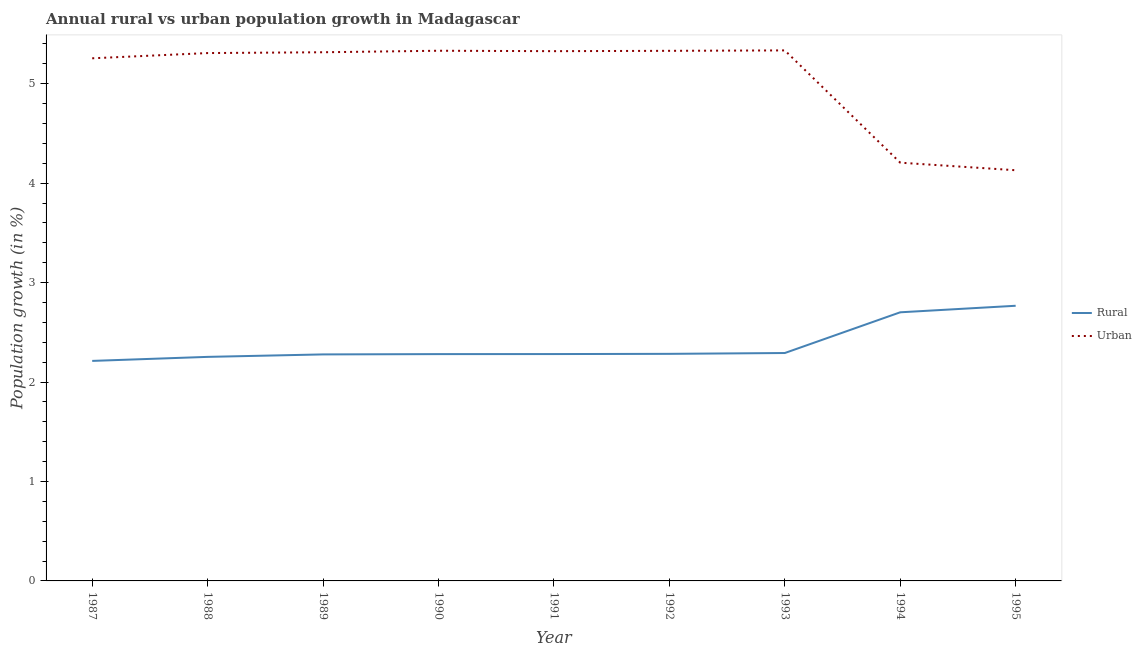What is the rural population growth in 1994?
Provide a short and direct response. 2.7. Across all years, what is the maximum rural population growth?
Provide a succinct answer. 2.77. Across all years, what is the minimum urban population growth?
Keep it short and to the point. 4.13. What is the total urban population growth in the graph?
Offer a terse response. 45.54. What is the difference between the urban population growth in 1989 and that in 1992?
Ensure brevity in your answer.  -0.01. What is the difference between the rural population growth in 1989 and the urban population growth in 1992?
Keep it short and to the point. -3.05. What is the average rural population growth per year?
Offer a very short reply. 2.37. In the year 1990, what is the difference between the rural population growth and urban population growth?
Make the answer very short. -3.05. What is the ratio of the rural population growth in 1993 to that in 1994?
Give a very brief answer. 0.85. Is the urban population growth in 1988 less than that in 1989?
Your response must be concise. Yes. What is the difference between the highest and the second highest urban population growth?
Offer a very short reply. 0. What is the difference between the highest and the lowest rural population growth?
Provide a short and direct response. 0.55. Is the urban population growth strictly less than the rural population growth over the years?
Make the answer very short. No. How many lines are there?
Your answer should be compact. 2. Does the graph contain any zero values?
Offer a terse response. No. Where does the legend appear in the graph?
Ensure brevity in your answer.  Center right. What is the title of the graph?
Your response must be concise. Annual rural vs urban population growth in Madagascar. Does "Age 65(male)" appear as one of the legend labels in the graph?
Make the answer very short. No. What is the label or title of the Y-axis?
Provide a succinct answer. Population growth (in %). What is the Population growth (in %) in Rural in 1987?
Give a very brief answer. 2.21. What is the Population growth (in %) of Urban  in 1987?
Your answer should be very brief. 5.26. What is the Population growth (in %) in Rural in 1988?
Give a very brief answer. 2.25. What is the Population growth (in %) in Urban  in 1988?
Your response must be concise. 5.31. What is the Population growth (in %) in Rural in 1989?
Your answer should be very brief. 2.28. What is the Population growth (in %) of Urban  in 1989?
Provide a short and direct response. 5.32. What is the Population growth (in %) of Rural in 1990?
Give a very brief answer. 2.28. What is the Population growth (in %) of Urban  in 1990?
Provide a short and direct response. 5.33. What is the Population growth (in %) of Rural in 1991?
Provide a short and direct response. 2.28. What is the Population growth (in %) of Urban  in 1991?
Ensure brevity in your answer.  5.33. What is the Population growth (in %) of Rural in 1992?
Ensure brevity in your answer.  2.28. What is the Population growth (in %) of Urban  in 1992?
Give a very brief answer. 5.33. What is the Population growth (in %) of Rural in 1993?
Offer a terse response. 2.29. What is the Population growth (in %) in Urban  in 1993?
Offer a very short reply. 5.33. What is the Population growth (in %) of Rural in 1994?
Offer a terse response. 2.7. What is the Population growth (in %) in Urban  in 1994?
Offer a terse response. 4.21. What is the Population growth (in %) of Rural in 1995?
Offer a terse response. 2.77. What is the Population growth (in %) in Urban  in 1995?
Your answer should be very brief. 4.13. Across all years, what is the maximum Population growth (in %) in Rural?
Your answer should be compact. 2.77. Across all years, what is the maximum Population growth (in %) in Urban ?
Your response must be concise. 5.33. Across all years, what is the minimum Population growth (in %) in Rural?
Keep it short and to the point. 2.21. Across all years, what is the minimum Population growth (in %) of Urban ?
Your response must be concise. 4.13. What is the total Population growth (in %) of Rural in the graph?
Provide a short and direct response. 21.35. What is the total Population growth (in %) in Urban  in the graph?
Offer a terse response. 45.54. What is the difference between the Population growth (in %) of Rural in 1987 and that in 1988?
Your answer should be very brief. -0.04. What is the difference between the Population growth (in %) in Urban  in 1987 and that in 1988?
Offer a very short reply. -0.05. What is the difference between the Population growth (in %) in Rural in 1987 and that in 1989?
Provide a succinct answer. -0.07. What is the difference between the Population growth (in %) in Urban  in 1987 and that in 1989?
Make the answer very short. -0.06. What is the difference between the Population growth (in %) in Rural in 1987 and that in 1990?
Offer a terse response. -0.07. What is the difference between the Population growth (in %) in Urban  in 1987 and that in 1990?
Provide a succinct answer. -0.08. What is the difference between the Population growth (in %) of Rural in 1987 and that in 1991?
Your answer should be very brief. -0.07. What is the difference between the Population growth (in %) of Urban  in 1987 and that in 1991?
Give a very brief answer. -0.07. What is the difference between the Population growth (in %) of Rural in 1987 and that in 1992?
Provide a short and direct response. -0.07. What is the difference between the Population growth (in %) of Urban  in 1987 and that in 1992?
Your response must be concise. -0.07. What is the difference between the Population growth (in %) in Rural in 1987 and that in 1993?
Ensure brevity in your answer.  -0.08. What is the difference between the Population growth (in %) of Urban  in 1987 and that in 1993?
Provide a succinct answer. -0.08. What is the difference between the Population growth (in %) of Rural in 1987 and that in 1994?
Your answer should be compact. -0.49. What is the difference between the Population growth (in %) of Urban  in 1987 and that in 1994?
Offer a very short reply. 1.05. What is the difference between the Population growth (in %) of Rural in 1987 and that in 1995?
Offer a terse response. -0.55. What is the difference between the Population growth (in %) of Urban  in 1987 and that in 1995?
Your answer should be very brief. 1.13. What is the difference between the Population growth (in %) in Rural in 1988 and that in 1989?
Your answer should be very brief. -0.02. What is the difference between the Population growth (in %) of Urban  in 1988 and that in 1989?
Keep it short and to the point. -0.01. What is the difference between the Population growth (in %) of Rural in 1988 and that in 1990?
Provide a short and direct response. -0.03. What is the difference between the Population growth (in %) in Urban  in 1988 and that in 1990?
Make the answer very short. -0.02. What is the difference between the Population growth (in %) of Rural in 1988 and that in 1991?
Provide a succinct answer. -0.03. What is the difference between the Population growth (in %) of Urban  in 1988 and that in 1991?
Offer a terse response. -0.02. What is the difference between the Population growth (in %) in Rural in 1988 and that in 1992?
Your answer should be very brief. -0.03. What is the difference between the Population growth (in %) in Urban  in 1988 and that in 1992?
Give a very brief answer. -0.02. What is the difference between the Population growth (in %) in Rural in 1988 and that in 1993?
Your answer should be compact. -0.04. What is the difference between the Population growth (in %) of Urban  in 1988 and that in 1993?
Your answer should be compact. -0.03. What is the difference between the Population growth (in %) of Rural in 1988 and that in 1994?
Your answer should be compact. -0.45. What is the difference between the Population growth (in %) of Urban  in 1988 and that in 1994?
Keep it short and to the point. 1.1. What is the difference between the Population growth (in %) in Rural in 1988 and that in 1995?
Ensure brevity in your answer.  -0.51. What is the difference between the Population growth (in %) of Urban  in 1988 and that in 1995?
Your answer should be very brief. 1.18. What is the difference between the Population growth (in %) of Rural in 1989 and that in 1990?
Provide a short and direct response. -0. What is the difference between the Population growth (in %) of Urban  in 1989 and that in 1990?
Offer a terse response. -0.02. What is the difference between the Population growth (in %) in Rural in 1989 and that in 1991?
Provide a succinct answer. -0. What is the difference between the Population growth (in %) of Urban  in 1989 and that in 1991?
Your answer should be compact. -0.01. What is the difference between the Population growth (in %) of Rural in 1989 and that in 1992?
Provide a short and direct response. -0.01. What is the difference between the Population growth (in %) in Urban  in 1989 and that in 1992?
Offer a very short reply. -0.01. What is the difference between the Population growth (in %) of Rural in 1989 and that in 1993?
Provide a succinct answer. -0.01. What is the difference between the Population growth (in %) in Urban  in 1989 and that in 1993?
Your response must be concise. -0.02. What is the difference between the Population growth (in %) in Rural in 1989 and that in 1994?
Make the answer very short. -0.42. What is the difference between the Population growth (in %) of Urban  in 1989 and that in 1994?
Ensure brevity in your answer.  1.11. What is the difference between the Population growth (in %) of Rural in 1989 and that in 1995?
Provide a succinct answer. -0.49. What is the difference between the Population growth (in %) in Urban  in 1989 and that in 1995?
Offer a very short reply. 1.19. What is the difference between the Population growth (in %) of Rural in 1990 and that in 1991?
Provide a succinct answer. -0. What is the difference between the Population growth (in %) in Urban  in 1990 and that in 1991?
Give a very brief answer. 0. What is the difference between the Population growth (in %) of Rural in 1990 and that in 1992?
Offer a terse response. -0. What is the difference between the Population growth (in %) in Urban  in 1990 and that in 1992?
Your answer should be very brief. 0. What is the difference between the Population growth (in %) in Rural in 1990 and that in 1993?
Give a very brief answer. -0.01. What is the difference between the Population growth (in %) of Urban  in 1990 and that in 1993?
Keep it short and to the point. -0. What is the difference between the Population growth (in %) in Rural in 1990 and that in 1994?
Offer a terse response. -0.42. What is the difference between the Population growth (in %) in Urban  in 1990 and that in 1994?
Provide a short and direct response. 1.13. What is the difference between the Population growth (in %) in Rural in 1990 and that in 1995?
Provide a short and direct response. -0.49. What is the difference between the Population growth (in %) in Urban  in 1990 and that in 1995?
Make the answer very short. 1.2. What is the difference between the Population growth (in %) of Rural in 1991 and that in 1992?
Ensure brevity in your answer.  -0. What is the difference between the Population growth (in %) in Urban  in 1991 and that in 1992?
Offer a terse response. -0. What is the difference between the Population growth (in %) of Rural in 1991 and that in 1993?
Give a very brief answer. -0.01. What is the difference between the Population growth (in %) of Urban  in 1991 and that in 1993?
Offer a very short reply. -0.01. What is the difference between the Population growth (in %) of Rural in 1991 and that in 1994?
Make the answer very short. -0.42. What is the difference between the Population growth (in %) in Urban  in 1991 and that in 1994?
Your response must be concise. 1.12. What is the difference between the Population growth (in %) of Rural in 1991 and that in 1995?
Make the answer very short. -0.49. What is the difference between the Population growth (in %) of Urban  in 1991 and that in 1995?
Your answer should be compact. 1.2. What is the difference between the Population growth (in %) in Rural in 1992 and that in 1993?
Offer a very short reply. -0.01. What is the difference between the Population growth (in %) of Urban  in 1992 and that in 1993?
Your answer should be very brief. -0. What is the difference between the Population growth (in %) of Rural in 1992 and that in 1994?
Offer a very short reply. -0.42. What is the difference between the Population growth (in %) in Urban  in 1992 and that in 1994?
Make the answer very short. 1.12. What is the difference between the Population growth (in %) of Rural in 1992 and that in 1995?
Offer a very short reply. -0.48. What is the difference between the Population growth (in %) in Urban  in 1992 and that in 1995?
Your answer should be very brief. 1.2. What is the difference between the Population growth (in %) of Rural in 1993 and that in 1994?
Offer a terse response. -0.41. What is the difference between the Population growth (in %) in Urban  in 1993 and that in 1994?
Keep it short and to the point. 1.13. What is the difference between the Population growth (in %) in Rural in 1993 and that in 1995?
Provide a succinct answer. -0.48. What is the difference between the Population growth (in %) of Urban  in 1993 and that in 1995?
Offer a terse response. 1.21. What is the difference between the Population growth (in %) in Rural in 1994 and that in 1995?
Provide a short and direct response. -0.07. What is the difference between the Population growth (in %) in Urban  in 1994 and that in 1995?
Your response must be concise. 0.08. What is the difference between the Population growth (in %) in Rural in 1987 and the Population growth (in %) in Urban  in 1988?
Offer a very short reply. -3.1. What is the difference between the Population growth (in %) in Rural in 1987 and the Population growth (in %) in Urban  in 1989?
Your answer should be compact. -3.1. What is the difference between the Population growth (in %) in Rural in 1987 and the Population growth (in %) in Urban  in 1990?
Your response must be concise. -3.12. What is the difference between the Population growth (in %) in Rural in 1987 and the Population growth (in %) in Urban  in 1991?
Provide a short and direct response. -3.11. What is the difference between the Population growth (in %) of Rural in 1987 and the Population growth (in %) of Urban  in 1992?
Your answer should be very brief. -3.12. What is the difference between the Population growth (in %) of Rural in 1987 and the Population growth (in %) of Urban  in 1993?
Provide a succinct answer. -3.12. What is the difference between the Population growth (in %) in Rural in 1987 and the Population growth (in %) in Urban  in 1994?
Keep it short and to the point. -1.99. What is the difference between the Population growth (in %) of Rural in 1987 and the Population growth (in %) of Urban  in 1995?
Provide a succinct answer. -1.92. What is the difference between the Population growth (in %) in Rural in 1988 and the Population growth (in %) in Urban  in 1989?
Make the answer very short. -3.06. What is the difference between the Population growth (in %) in Rural in 1988 and the Population growth (in %) in Urban  in 1990?
Your answer should be compact. -3.08. What is the difference between the Population growth (in %) of Rural in 1988 and the Population growth (in %) of Urban  in 1991?
Offer a very short reply. -3.07. What is the difference between the Population growth (in %) of Rural in 1988 and the Population growth (in %) of Urban  in 1992?
Provide a succinct answer. -3.08. What is the difference between the Population growth (in %) in Rural in 1988 and the Population growth (in %) in Urban  in 1993?
Your response must be concise. -3.08. What is the difference between the Population growth (in %) of Rural in 1988 and the Population growth (in %) of Urban  in 1994?
Provide a succinct answer. -1.95. What is the difference between the Population growth (in %) of Rural in 1988 and the Population growth (in %) of Urban  in 1995?
Your answer should be very brief. -1.88. What is the difference between the Population growth (in %) of Rural in 1989 and the Population growth (in %) of Urban  in 1990?
Your answer should be very brief. -3.05. What is the difference between the Population growth (in %) in Rural in 1989 and the Population growth (in %) in Urban  in 1991?
Your answer should be compact. -3.05. What is the difference between the Population growth (in %) in Rural in 1989 and the Population growth (in %) in Urban  in 1992?
Make the answer very short. -3.05. What is the difference between the Population growth (in %) in Rural in 1989 and the Population growth (in %) in Urban  in 1993?
Keep it short and to the point. -3.06. What is the difference between the Population growth (in %) of Rural in 1989 and the Population growth (in %) of Urban  in 1994?
Your response must be concise. -1.93. What is the difference between the Population growth (in %) in Rural in 1989 and the Population growth (in %) in Urban  in 1995?
Give a very brief answer. -1.85. What is the difference between the Population growth (in %) in Rural in 1990 and the Population growth (in %) in Urban  in 1991?
Provide a succinct answer. -3.05. What is the difference between the Population growth (in %) of Rural in 1990 and the Population growth (in %) of Urban  in 1992?
Give a very brief answer. -3.05. What is the difference between the Population growth (in %) of Rural in 1990 and the Population growth (in %) of Urban  in 1993?
Your answer should be compact. -3.05. What is the difference between the Population growth (in %) in Rural in 1990 and the Population growth (in %) in Urban  in 1994?
Your answer should be very brief. -1.92. What is the difference between the Population growth (in %) in Rural in 1990 and the Population growth (in %) in Urban  in 1995?
Your response must be concise. -1.85. What is the difference between the Population growth (in %) of Rural in 1991 and the Population growth (in %) of Urban  in 1992?
Your answer should be very brief. -3.05. What is the difference between the Population growth (in %) in Rural in 1991 and the Population growth (in %) in Urban  in 1993?
Your answer should be very brief. -3.05. What is the difference between the Population growth (in %) in Rural in 1991 and the Population growth (in %) in Urban  in 1994?
Make the answer very short. -1.92. What is the difference between the Population growth (in %) of Rural in 1991 and the Population growth (in %) of Urban  in 1995?
Your answer should be very brief. -1.85. What is the difference between the Population growth (in %) in Rural in 1992 and the Population growth (in %) in Urban  in 1993?
Provide a short and direct response. -3.05. What is the difference between the Population growth (in %) in Rural in 1992 and the Population growth (in %) in Urban  in 1994?
Your answer should be compact. -1.92. What is the difference between the Population growth (in %) of Rural in 1992 and the Population growth (in %) of Urban  in 1995?
Provide a short and direct response. -1.85. What is the difference between the Population growth (in %) of Rural in 1993 and the Population growth (in %) of Urban  in 1994?
Your answer should be compact. -1.91. What is the difference between the Population growth (in %) in Rural in 1993 and the Population growth (in %) in Urban  in 1995?
Your answer should be compact. -1.84. What is the difference between the Population growth (in %) in Rural in 1994 and the Population growth (in %) in Urban  in 1995?
Keep it short and to the point. -1.43. What is the average Population growth (in %) of Rural per year?
Provide a succinct answer. 2.37. What is the average Population growth (in %) of Urban  per year?
Provide a short and direct response. 5.06. In the year 1987, what is the difference between the Population growth (in %) in Rural and Population growth (in %) in Urban ?
Provide a succinct answer. -3.04. In the year 1988, what is the difference between the Population growth (in %) of Rural and Population growth (in %) of Urban ?
Ensure brevity in your answer.  -3.05. In the year 1989, what is the difference between the Population growth (in %) in Rural and Population growth (in %) in Urban ?
Provide a succinct answer. -3.04. In the year 1990, what is the difference between the Population growth (in %) of Rural and Population growth (in %) of Urban ?
Ensure brevity in your answer.  -3.05. In the year 1991, what is the difference between the Population growth (in %) of Rural and Population growth (in %) of Urban ?
Your response must be concise. -3.05. In the year 1992, what is the difference between the Population growth (in %) of Rural and Population growth (in %) of Urban ?
Ensure brevity in your answer.  -3.05. In the year 1993, what is the difference between the Population growth (in %) of Rural and Population growth (in %) of Urban ?
Offer a very short reply. -3.04. In the year 1994, what is the difference between the Population growth (in %) of Rural and Population growth (in %) of Urban ?
Keep it short and to the point. -1.5. In the year 1995, what is the difference between the Population growth (in %) of Rural and Population growth (in %) of Urban ?
Make the answer very short. -1.36. What is the ratio of the Population growth (in %) in Rural in 1987 to that in 1988?
Keep it short and to the point. 0.98. What is the ratio of the Population growth (in %) of Rural in 1987 to that in 1989?
Your response must be concise. 0.97. What is the ratio of the Population growth (in %) of Urban  in 1987 to that in 1989?
Offer a terse response. 0.99. What is the ratio of the Population growth (in %) in Urban  in 1987 to that in 1990?
Provide a succinct answer. 0.99. What is the ratio of the Population growth (in %) of Rural in 1987 to that in 1991?
Make the answer very short. 0.97. What is the ratio of the Population growth (in %) in Urban  in 1987 to that in 1991?
Provide a succinct answer. 0.99. What is the ratio of the Population growth (in %) of Rural in 1987 to that in 1992?
Provide a succinct answer. 0.97. What is the ratio of the Population growth (in %) of Urban  in 1987 to that in 1992?
Your answer should be very brief. 0.99. What is the ratio of the Population growth (in %) of Rural in 1987 to that in 1993?
Your response must be concise. 0.97. What is the ratio of the Population growth (in %) in Urban  in 1987 to that in 1993?
Keep it short and to the point. 0.99. What is the ratio of the Population growth (in %) of Rural in 1987 to that in 1994?
Ensure brevity in your answer.  0.82. What is the ratio of the Population growth (in %) in Urban  in 1987 to that in 1994?
Make the answer very short. 1.25. What is the ratio of the Population growth (in %) of Rural in 1987 to that in 1995?
Offer a very short reply. 0.8. What is the ratio of the Population growth (in %) in Urban  in 1987 to that in 1995?
Provide a short and direct response. 1.27. What is the ratio of the Population growth (in %) of Urban  in 1988 to that in 1990?
Keep it short and to the point. 1. What is the ratio of the Population growth (in %) in Rural in 1988 to that in 1991?
Give a very brief answer. 0.99. What is the ratio of the Population growth (in %) in Urban  in 1988 to that in 1991?
Keep it short and to the point. 1. What is the ratio of the Population growth (in %) in Rural in 1988 to that in 1992?
Ensure brevity in your answer.  0.99. What is the ratio of the Population growth (in %) of Rural in 1988 to that in 1993?
Give a very brief answer. 0.98. What is the ratio of the Population growth (in %) in Urban  in 1988 to that in 1993?
Offer a very short reply. 0.99. What is the ratio of the Population growth (in %) of Rural in 1988 to that in 1994?
Ensure brevity in your answer.  0.83. What is the ratio of the Population growth (in %) in Urban  in 1988 to that in 1994?
Offer a very short reply. 1.26. What is the ratio of the Population growth (in %) of Rural in 1988 to that in 1995?
Provide a succinct answer. 0.81. What is the ratio of the Population growth (in %) of Urban  in 1988 to that in 1995?
Give a very brief answer. 1.29. What is the ratio of the Population growth (in %) in Rural in 1989 to that in 1990?
Give a very brief answer. 1. What is the ratio of the Population growth (in %) in Urban  in 1989 to that in 1990?
Ensure brevity in your answer.  1. What is the ratio of the Population growth (in %) of Rural in 1989 to that in 1991?
Make the answer very short. 1. What is the ratio of the Population growth (in %) in Urban  in 1989 to that in 1993?
Offer a very short reply. 1. What is the ratio of the Population growth (in %) in Rural in 1989 to that in 1994?
Give a very brief answer. 0.84. What is the ratio of the Population growth (in %) in Urban  in 1989 to that in 1994?
Make the answer very short. 1.26. What is the ratio of the Population growth (in %) in Rural in 1989 to that in 1995?
Keep it short and to the point. 0.82. What is the ratio of the Population growth (in %) in Urban  in 1989 to that in 1995?
Provide a succinct answer. 1.29. What is the ratio of the Population growth (in %) of Rural in 1990 to that in 1992?
Your answer should be very brief. 1. What is the ratio of the Population growth (in %) in Urban  in 1990 to that in 1992?
Your response must be concise. 1. What is the ratio of the Population growth (in %) in Rural in 1990 to that in 1994?
Make the answer very short. 0.84. What is the ratio of the Population growth (in %) in Urban  in 1990 to that in 1994?
Give a very brief answer. 1.27. What is the ratio of the Population growth (in %) of Rural in 1990 to that in 1995?
Provide a succinct answer. 0.82. What is the ratio of the Population growth (in %) of Urban  in 1990 to that in 1995?
Offer a terse response. 1.29. What is the ratio of the Population growth (in %) of Urban  in 1991 to that in 1992?
Make the answer very short. 1. What is the ratio of the Population growth (in %) in Rural in 1991 to that in 1993?
Your response must be concise. 1. What is the ratio of the Population growth (in %) of Rural in 1991 to that in 1994?
Offer a terse response. 0.84. What is the ratio of the Population growth (in %) of Urban  in 1991 to that in 1994?
Ensure brevity in your answer.  1.27. What is the ratio of the Population growth (in %) of Rural in 1991 to that in 1995?
Your answer should be very brief. 0.82. What is the ratio of the Population growth (in %) of Urban  in 1991 to that in 1995?
Your response must be concise. 1.29. What is the ratio of the Population growth (in %) of Urban  in 1992 to that in 1993?
Your answer should be very brief. 1. What is the ratio of the Population growth (in %) in Rural in 1992 to that in 1994?
Provide a short and direct response. 0.85. What is the ratio of the Population growth (in %) in Urban  in 1992 to that in 1994?
Ensure brevity in your answer.  1.27. What is the ratio of the Population growth (in %) in Rural in 1992 to that in 1995?
Offer a terse response. 0.83. What is the ratio of the Population growth (in %) of Urban  in 1992 to that in 1995?
Provide a succinct answer. 1.29. What is the ratio of the Population growth (in %) of Rural in 1993 to that in 1994?
Keep it short and to the point. 0.85. What is the ratio of the Population growth (in %) in Urban  in 1993 to that in 1994?
Provide a short and direct response. 1.27. What is the ratio of the Population growth (in %) in Rural in 1993 to that in 1995?
Your answer should be very brief. 0.83. What is the ratio of the Population growth (in %) of Urban  in 1993 to that in 1995?
Make the answer very short. 1.29. What is the ratio of the Population growth (in %) of Rural in 1994 to that in 1995?
Ensure brevity in your answer.  0.98. What is the ratio of the Population growth (in %) in Urban  in 1994 to that in 1995?
Offer a terse response. 1.02. What is the difference between the highest and the second highest Population growth (in %) in Rural?
Your answer should be compact. 0.07. What is the difference between the highest and the second highest Population growth (in %) of Urban ?
Provide a succinct answer. 0. What is the difference between the highest and the lowest Population growth (in %) of Rural?
Give a very brief answer. 0.55. What is the difference between the highest and the lowest Population growth (in %) in Urban ?
Provide a succinct answer. 1.21. 